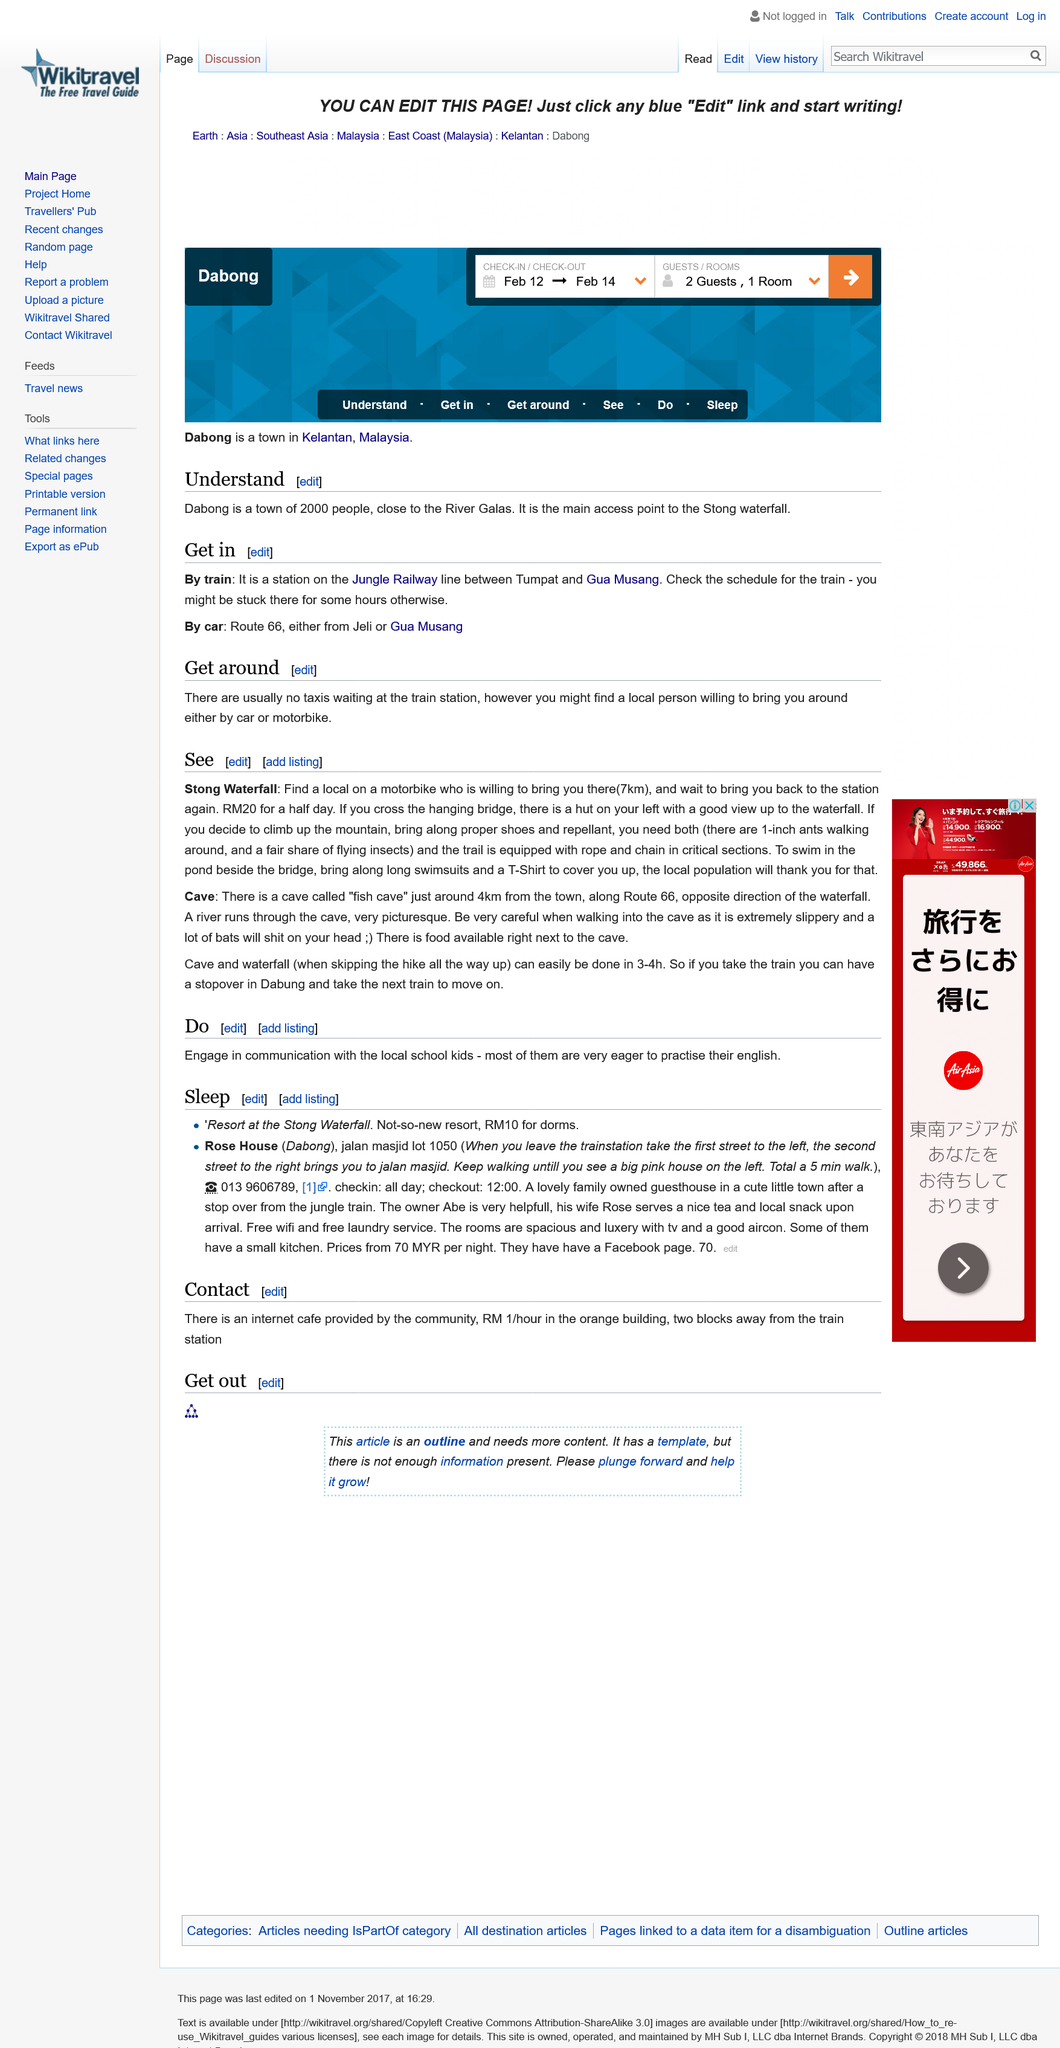Outline some significant characteristics in this image. The fish cave is a notable cave located in a remote area, accessible only by train. It is a significant site for the local community and is known for its underground lakes and unique geological features. It is possible to skip the hike all the way up in 3-4 hours. Swimming in the pond beside the bridge requires bringing two items of clothing to cover oneself: a long swimsuit and a T-shirt. 